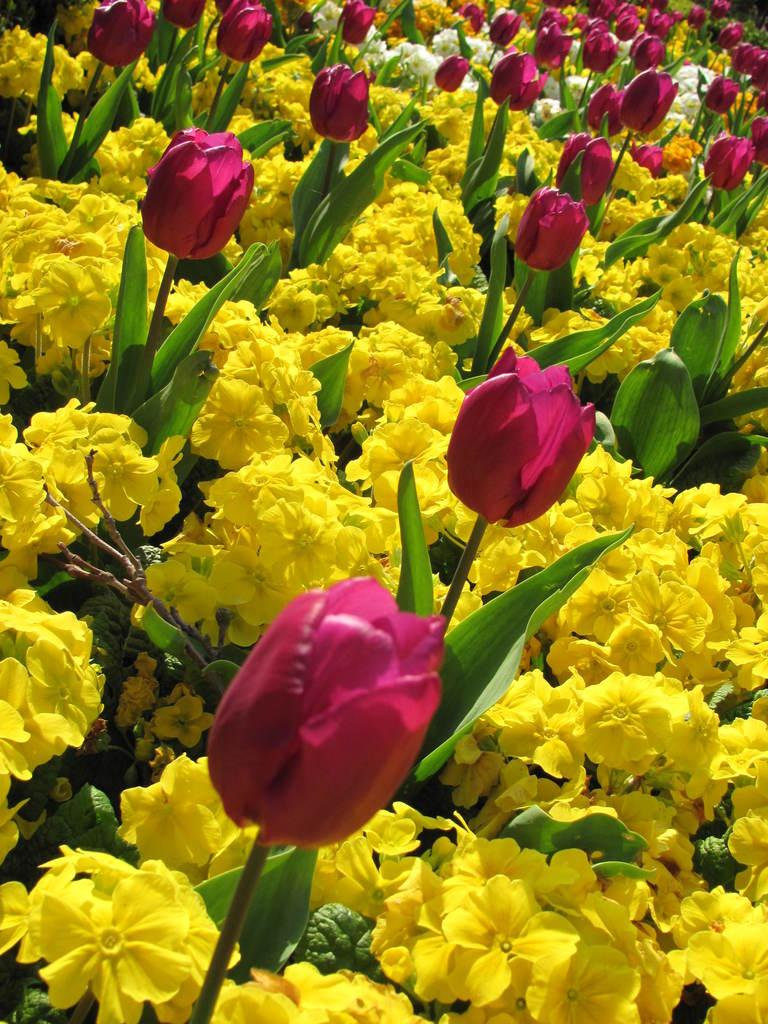What is the predominant color of the flowers in the image? There are many yellow flowers in the image. Are there any other colors of flowers present? Yes, there are pink tulips in the image. What color are the flowers in the background of the image? The flowers in the background of the image are white. How many brothers are holding hands in the image? There are no brothers present in the image; it features flowers. 